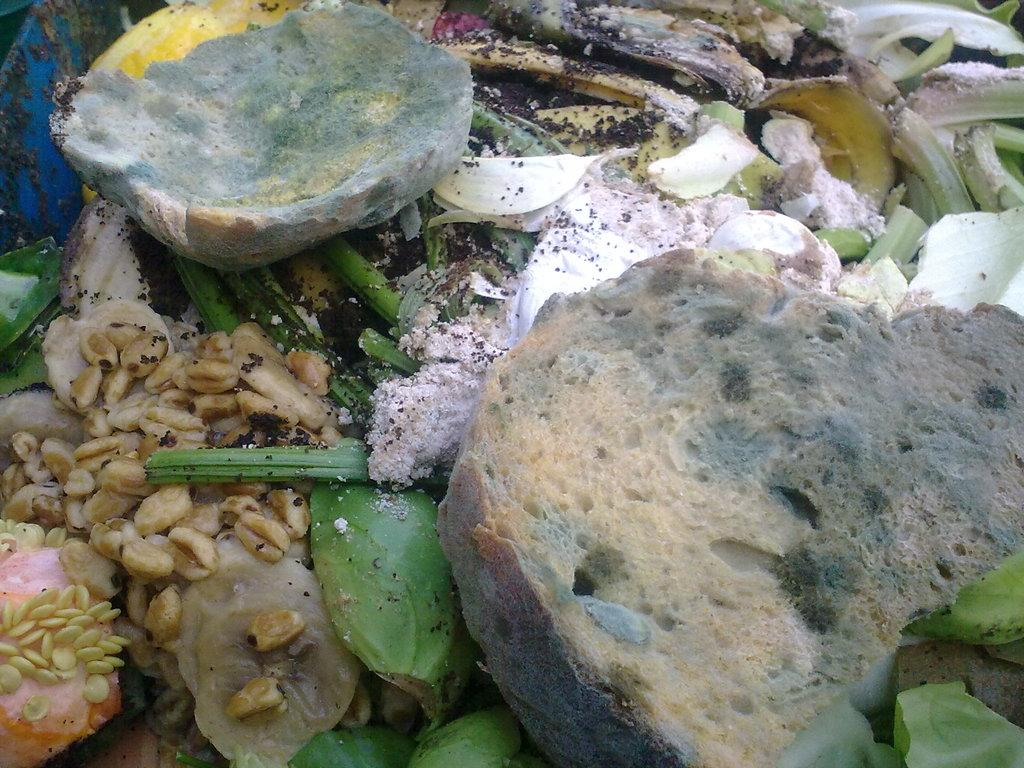What type of items can be seen in the image? There are garbage items in the image. What type of wave can be seen crashing on the garbage items in the image? There is no wave present in the image; it only shows garbage items. 